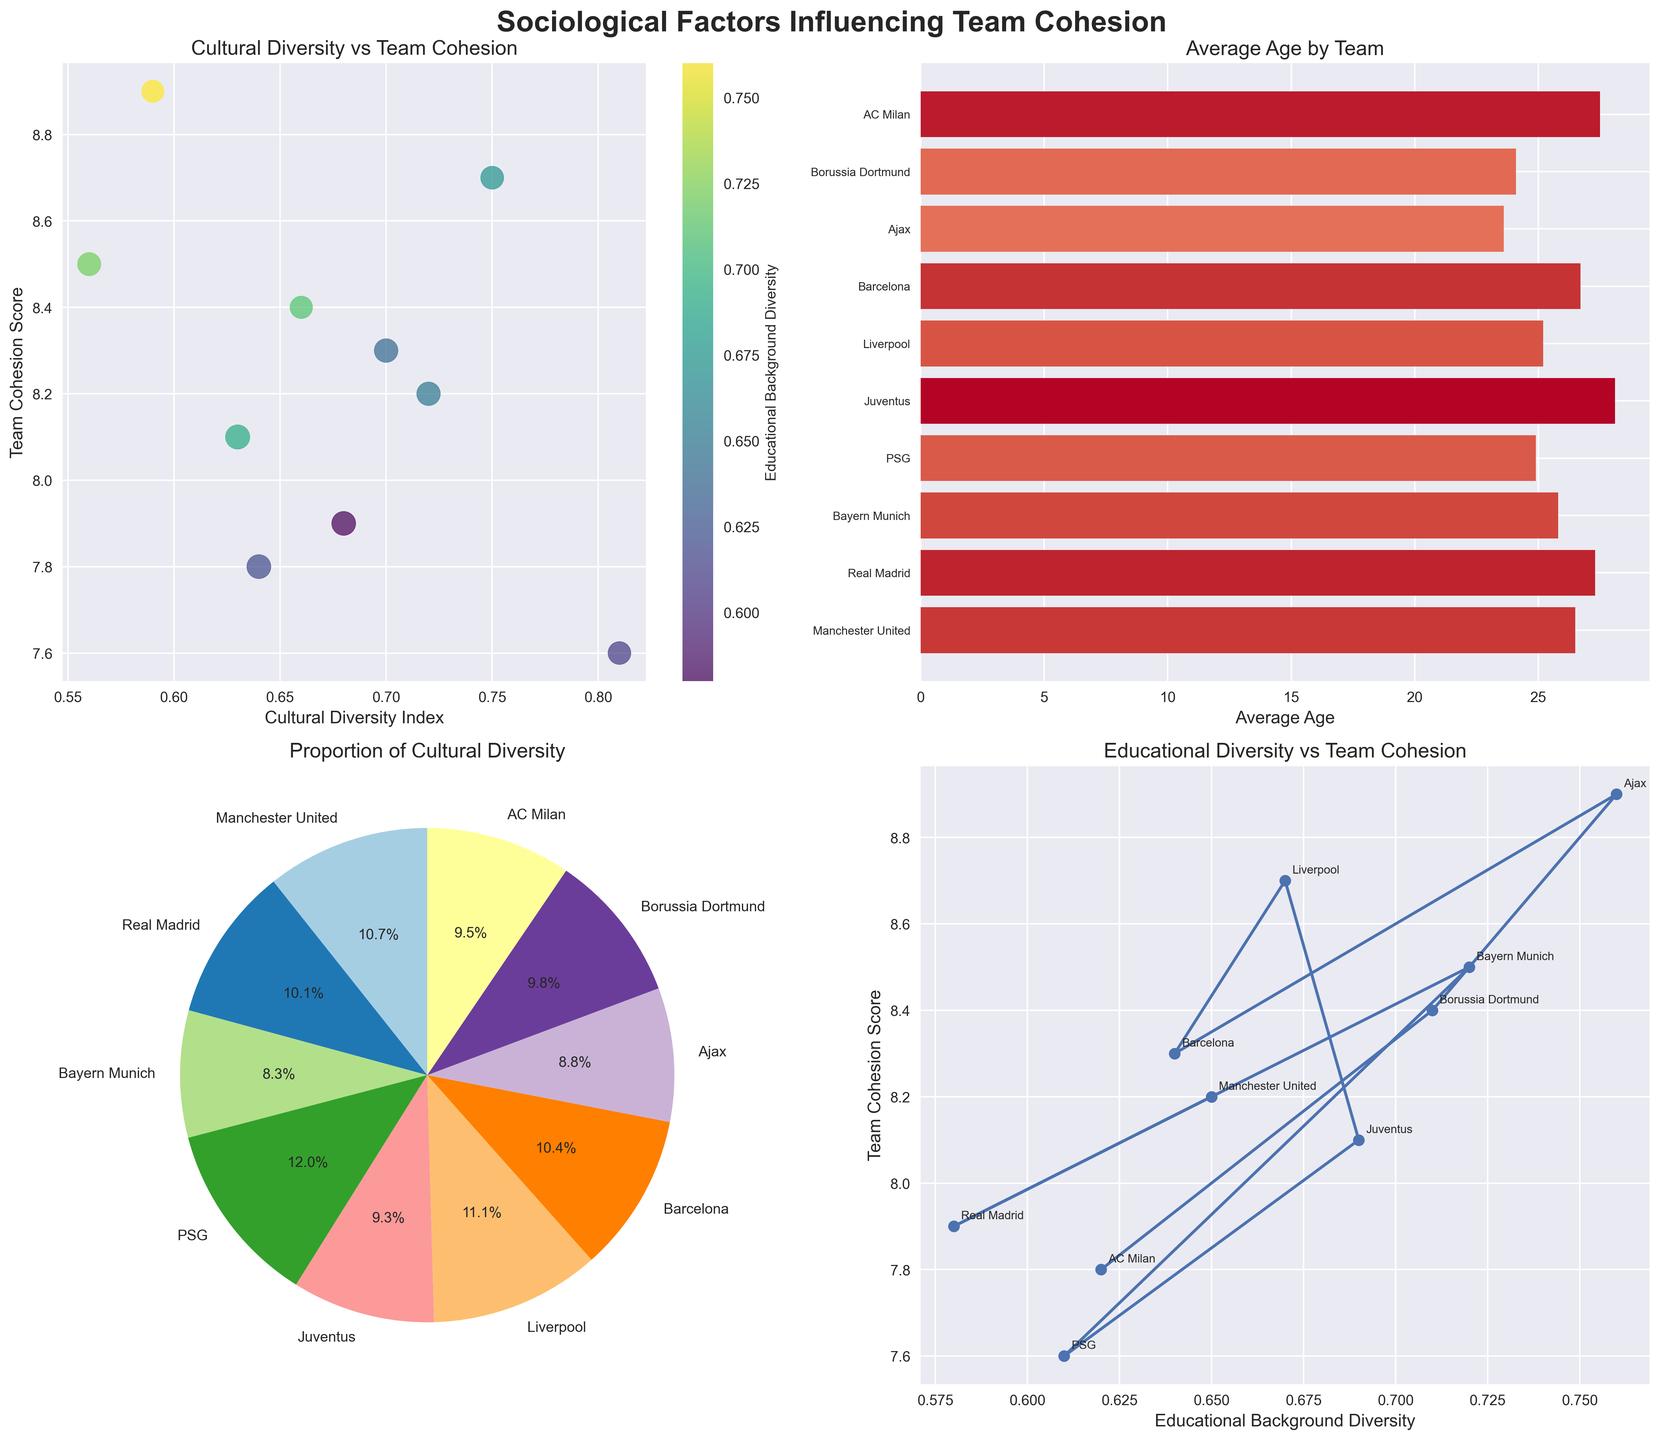How does the Cultural Diversity Index relate to Team Cohesion Score? The scatter plot shows the correlation between Cultural Diversity Index and Team Cohesion Score; by observing the scatter plot, we can determine if higher cultural diversity relates to higher or lower team cohesion scores.
Answer: The Cultural Diversity Index appears to correlate positively with the Team Cohesion Score, but there are some variations Which team has the highest Team Cohesion Score, and what is their Cultural Diversity Index? Looking at the scatter plot, identify the highest point on the y-axis, which represents the Team Cohesion Score, and note the x-axis value associated with it.
Answer: Ajax, with a Team Cohesion Score of 8.9 and a Cultural Diversity Index of 0.59 What is the range of team average ages in the bar plot? By observing the leftmost and rightmost points of the horizontal bars in the bar plot, determine the minimum and maximum average ages.
Answer: 23.6 to 28.1 Which team accounts for the largest proportion of cultural diversity? In the pie chart, identify the segment with the largest area and read its label.
Answer: PSG with 8.1% How does Educational Background Diversity affect Team Cohesion Score? Analyze the line plot where the x-axis represents Educational Background Diversity and the y-axis represents Team Cohesion Score to identify any trends or patterns.
Answer: Higher Educational Background Diversity generally results in slightly higher Team Cohesion Scores Compare Juventus and Real Madrid regarding their Average Age and Team Cohesion Score. Refer to the bar plot to get their average ages and compare their y-values in the scatter plot to get their Team Cohesion Scores. Real Madrid's average age is 27.3 and their Team Cohesion Score is 7.9, while Juventus' average age is 28.1 and their Team Cohesion Score is 8.1.
Answer: Juventus has a higher average age (28.1 vs. 27.3) and a higher Team Cohesion Score (8.1 vs. 7.9) than Real Madrid How does Liverpool compare to AC Milan in terms of Educational Background Diversity and Team Cohesion Score? Locate Liverpool and AC Milan in the line plot and compare their x-values for Educational Background Diversity and their y-values for Team Cohesion Score. Liverpool's diversity is 0.67 with a cohesion score of 8.7; AC Milan's diversity is 0.62 with a cohesion score of 7.8.
Answer: Liverpool has both higher Educational Background Diversity (0.67) and Team Cohesion Score (8.7) Which team has the lowest cultural diversity, and what is its Team Cohesion Score? From the scatter plot, identify the point with the lowest x-axis value and note its corresponding y-axis value.
Answer: Ajax, with a Team Cohesion Score of 8.9 Is there any team whose average age is above 27 and has an Educational Background Diversity above 0.65? Check the bar plot to list teams with an average age above 27 and confirm their Educational Background Diversity from the scatter plot legend. Juventus' average age is above 27 and their Educational Background Diversity is above 0.65.
Answer: Juventus Which three teams contribute the least to cultural diversity based on the pie chart? Identify and list the three smallest segments in the pie chart along with their labels.
Answer: Ajax, Borussia Dortmund, and AC Milan 